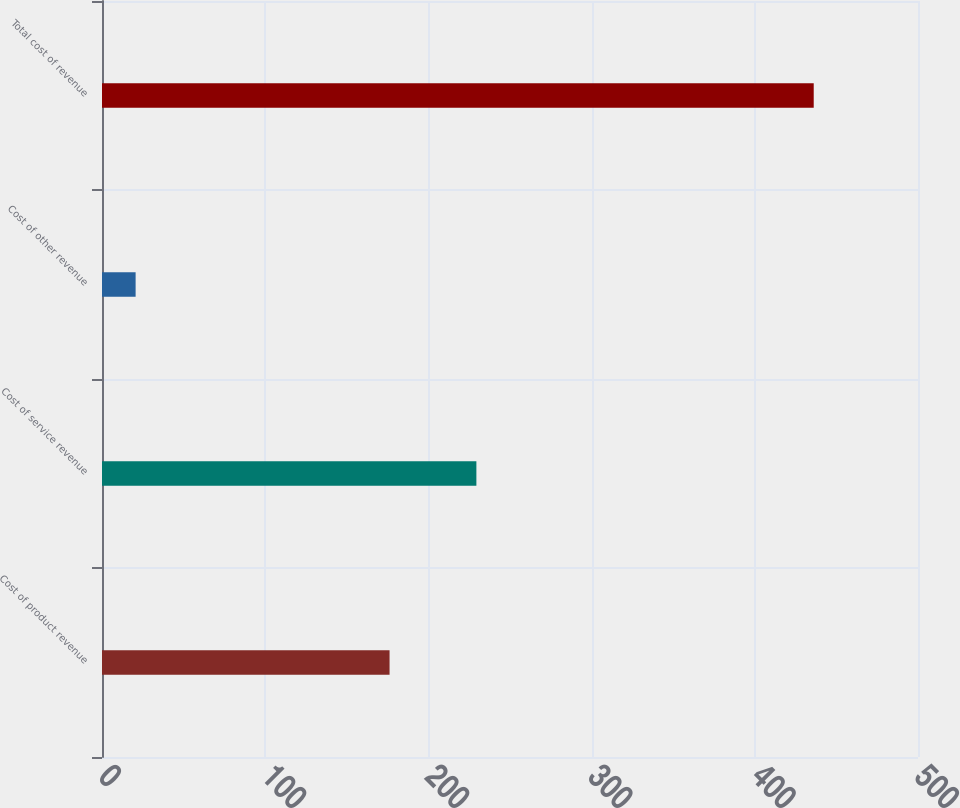Convert chart to OTSL. <chart><loc_0><loc_0><loc_500><loc_500><bar_chart><fcel>Cost of product revenue<fcel>Cost of service revenue<fcel>Cost of other revenue<fcel>Total cost of revenue<nl><fcel>176.2<fcel>229.4<fcel>20.6<fcel>436.1<nl></chart> 